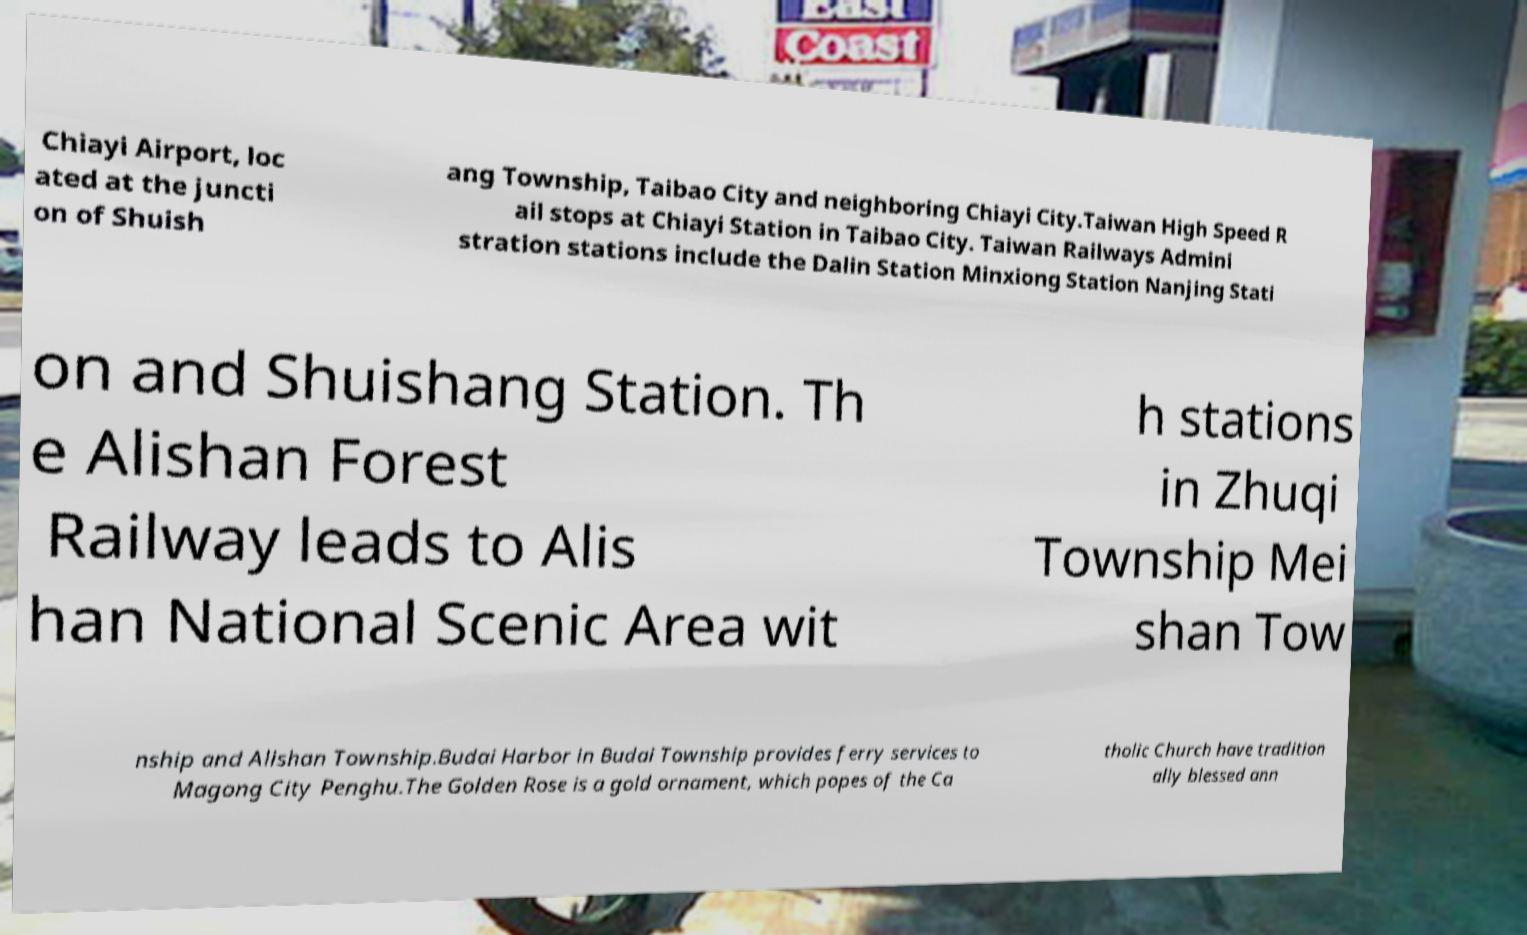Can you read and provide the text displayed in the image?This photo seems to have some interesting text. Can you extract and type it out for me? Chiayi Airport, loc ated at the juncti on of Shuish ang Township, Taibao City and neighboring Chiayi City.Taiwan High Speed R ail stops at Chiayi Station in Taibao City. Taiwan Railways Admini stration stations include the Dalin Station Minxiong Station Nanjing Stati on and Shuishang Station. Th e Alishan Forest Railway leads to Alis han National Scenic Area wit h stations in Zhuqi Township Mei shan Tow nship and Alishan Township.Budai Harbor in Budai Township provides ferry services to Magong City Penghu.The Golden Rose is a gold ornament, which popes of the Ca tholic Church have tradition ally blessed ann 